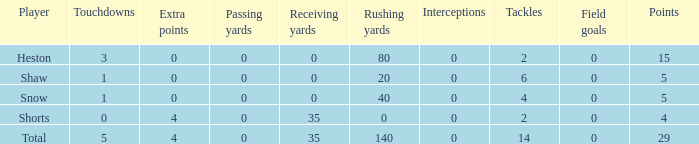What is the sum of all the touchdowns when the player had more than 0 extra points and less than 0 field goals? None. Parse the table in full. {'header': ['Player', 'Touchdowns', 'Extra points', 'Passing yards', 'Receiving yards', 'Rushing yards', 'Interceptions', 'Tackles', 'Field goals', 'Points'], 'rows': [['Heston', '3', '0', '0', '0', '80', '0', '2', '0', '15'], ['Shaw', '1', '0', '0', '0', '20', '0', '6', '0', '5'], ['Snow', '1', '0', '0', '0', '40', '0', '4', '0', '5'], ['Shorts', '0', '4', '0', '35', '0', '0', '2', '0', '4'], ['Total', '5', '4', '0', '35', '140', '0', '14', '0', '29']]} 